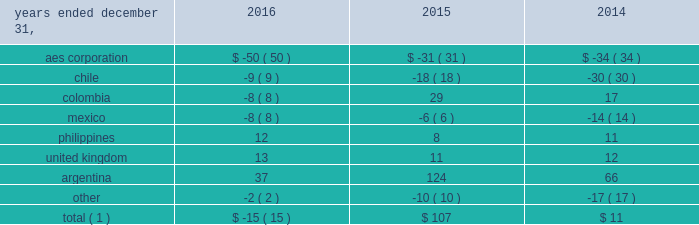The net decrease in the 2016 effective tax rate was due , in part , to the 2016 asset impairments in the u.s .
And to the current year benefit related to a restructuring of one of our brazilian businesses that increases tax basis in long-term assets .
Further , the 2015 rate was impacted by the items described below .
See note 20 2014asset impairment expense for additional information regarding the 2016 u.s .
Asset impairments .
Income tax expense increased $ 101 million , or 27% ( 27 % ) , to $ 472 million in 2015 .
The company's effective tax rates were 41% ( 41 % ) and 26% ( 26 % ) for the years ended december 31 , 2015 and 2014 , respectively .
The net increase in the 2015 effective tax rate was due , in part , to the nondeductible 2015 impairment of goodwill at our u.s .
Utility , dp&l and chilean withholding taxes offset by the release of valuation allowance at certain of our businesses in brazil , vietnam and the u.s .
Further , the 2014 rate was impacted by the sale of approximately 45% ( 45 % ) of the company 2019s interest in masin aes pte ltd. , which owns the company 2019s business interests in the philippines and the 2014 sale of the company 2019s interests in four u.k .
Wind operating projects .
Neither of these transactions gave rise to income tax expense .
See note 15 2014equity for additional information regarding the sale of approximately 45% ( 45 % ) of the company 2019s interest in masin-aes pte ltd .
See note 23 2014dispositions for additional information regarding the sale of the company 2019s interests in four u.k .
Wind operating projects .
Our effective tax rate reflects the tax effect of significant operations outside the u.s. , which are generally taxed at rates lower than the u.s .
Statutory rate of 35% ( 35 % ) .
A future proportionate change in the composition of income before income taxes from foreign and domestic tax jurisdictions could impact our periodic effective tax rate .
The company also benefits from reduced tax rates in certain countries as a result of satisfying specific commitments regarding employment and capital investment .
See note 21 2014income taxes for additional information regarding these reduced rates .
Foreign currency transaction gains ( losses ) foreign currency transaction gains ( losses ) in millions were as follows: .
Total ( 1 ) $ ( 15 ) $ 107 $ 11 _____________________________ ( 1 ) includes gains of $ 17 million , $ 247 million and $ 172 million on foreign currency derivative contracts for the years ended december 31 , 2016 , 2015 and 2014 , respectively .
The company recognized a net foreign currency transaction loss of $ 15 million for the year ended december 31 , 2016 primarily due to losses of $ 50 million at the aes corporation mainly due to remeasurement losses on intercompany notes , and losses on swaps and options .
This loss was partially offset by gains of $ 37 million in argentina , mainly due to the favorable impact of foreign currency derivatives related to government receivables .
The company recognized a net foreign currency transaction gain of $ 107 million for the year ended december 31 , 2015 primarily due to gains of : 2022 $ 124 million in argentina , due to the favorable impact from foreign currency derivatives related to government receivables , partially offset by losses from the devaluation of the argentine peso associated with u.s .
Dollar denominated debt , and losses at termoandes ( a u.s .
Dollar functional currency subsidiary ) primarily associated with cash and accounts receivable balances in local currency , 2022 $ 29 million in colombia , mainly due to the depreciation of the colombian peso , positively impacting chivor ( a u.s .
Dollar functional currency subsidiary ) due to liabilities denominated in colombian pesos , 2022 $ 11 million in the united kingdom , mainly due to the depreciation of the pound sterling , resulting in gains at ballylumford holdings ( a u.s .
Dollar functional currency subsidiary ) associated with intercompany notes payable denominated in pound sterling , and .
What was the average effective tax rate for december 31 , 2015 and 2014? 
Computations: ((41 + 26) / 2)
Answer: 33.5. 